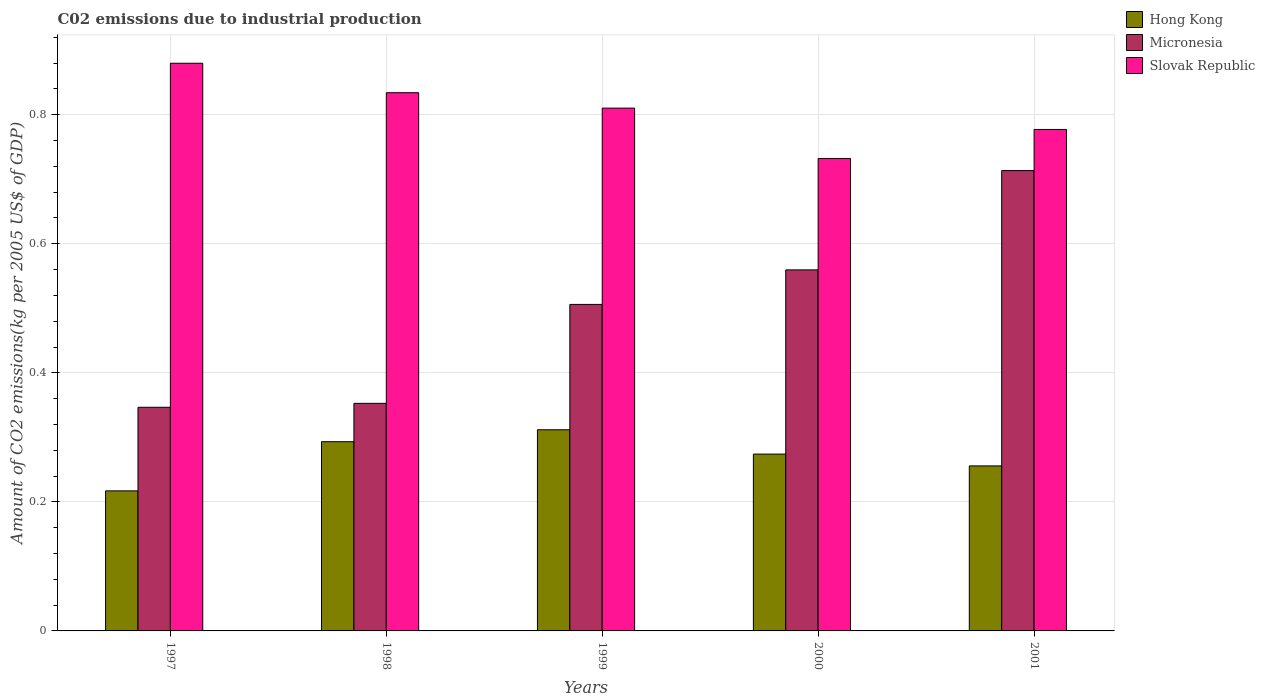How many different coloured bars are there?
Keep it short and to the point. 3. Are the number of bars on each tick of the X-axis equal?
Offer a terse response. Yes. What is the label of the 5th group of bars from the left?
Your answer should be very brief. 2001. In how many cases, is the number of bars for a given year not equal to the number of legend labels?
Offer a very short reply. 0. What is the amount of CO2 emitted due to industrial production in Slovak Republic in 2001?
Ensure brevity in your answer.  0.78. Across all years, what is the maximum amount of CO2 emitted due to industrial production in Micronesia?
Give a very brief answer. 0.71. Across all years, what is the minimum amount of CO2 emitted due to industrial production in Hong Kong?
Your response must be concise. 0.22. In which year was the amount of CO2 emitted due to industrial production in Hong Kong maximum?
Offer a terse response. 1999. What is the total amount of CO2 emitted due to industrial production in Hong Kong in the graph?
Provide a short and direct response. 1.35. What is the difference between the amount of CO2 emitted due to industrial production in Hong Kong in 1998 and that in 2000?
Keep it short and to the point. 0.02. What is the difference between the amount of CO2 emitted due to industrial production in Micronesia in 2000 and the amount of CO2 emitted due to industrial production in Slovak Republic in 1998?
Keep it short and to the point. -0.27. What is the average amount of CO2 emitted due to industrial production in Micronesia per year?
Give a very brief answer. 0.5. In the year 1997, what is the difference between the amount of CO2 emitted due to industrial production in Hong Kong and amount of CO2 emitted due to industrial production in Slovak Republic?
Offer a terse response. -0.66. In how many years, is the amount of CO2 emitted due to industrial production in Micronesia greater than 0.6000000000000001 kg?
Offer a very short reply. 1. What is the ratio of the amount of CO2 emitted due to industrial production in Slovak Republic in 1998 to that in 2001?
Offer a very short reply. 1.07. Is the amount of CO2 emitted due to industrial production in Slovak Republic in 1997 less than that in 1998?
Your answer should be compact. No. Is the difference between the amount of CO2 emitted due to industrial production in Hong Kong in 1997 and 1999 greater than the difference between the amount of CO2 emitted due to industrial production in Slovak Republic in 1997 and 1999?
Ensure brevity in your answer.  No. What is the difference between the highest and the second highest amount of CO2 emitted due to industrial production in Slovak Republic?
Your answer should be compact. 0.05. What is the difference between the highest and the lowest amount of CO2 emitted due to industrial production in Slovak Republic?
Your response must be concise. 0.15. Is the sum of the amount of CO2 emitted due to industrial production in Slovak Republic in 1998 and 2001 greater than the maximum amount of CO2 emitted due to industrial production in Micronesia across all years?
Keep it short and to the point. Yes. What does the 2nd bar from the left in 2001 represents?
Provide a succinct answer. Micronesia. What does the 3rd bar from the right in 1999 represents?
Keep it short and to the point. Hong Kong. Is it the case that in every year, the sum of the amount of CO2 emitted due to industrial production in Slovak Republic and amount of CO2 emitted due to industrial production in Micronesia is greater than the amount of CO2 emitted due to industrial production in Hong Kong?
Your answer should be very brief. Yes. Are the values on the major ticks of Y-axis written in scientific E-notation?
Your answer should be very brief. No. What is the title of the graph?
Provide a succinct answer. C02 emissions due to industrial production. Does "Canada" appear as one of the legend labels in the graph?
Make the answer very short. No. What is the label or title of the X-axis?
Ensure brevity in your answer.  Years. What is the label or title of the Y-axis?
Your response must be concise. Amount of CO2 emissions(kg per 2005 US$ of GDP). What is the Amount of CO2 emissions(kg per 2005 US$ of GDP) of Hong Kong in 1997?
Provide a short and direct response. 0.22. What is the Amount of CO2 emissions(kg per 2005 US$ of GDP) of Micronesia in 1997?
Ensure brevity in your answer.  0.35. What is the Amount of CO2 emissions(kg per 2005 US$ of GDP) in Slovak Republic in 1997?
Give a very brief answer. 0.88. What is the Amount of CO2 emissions(kg per 2005 US$ of GDP) of Hong Kong in 1998?
Your answer should be very brief. 0.29. What is the Amount of CO2 emissions(kg per 2005 US$ of GDP) in Micronesia in 1998?
Your answer should be very brief. 0.35. What is the Amount of CO2 emissions(kg per 2005 US$ of GDP) in Slovak Republic in 1998?
Your answer should be compact. 0.83. What is the Amount of CO2 emissions(kg per 2005 US$ of GDP) of Hong Kong in 1999?
Provide a succinct answer. 0.31. What is the Amount of CO2 emissions(kg per 2005 US$ of GDP) of Micronesia in 1999?
Make the answer very short. 0.51. What is the Amount of CO2 emissions(kg per 2005 US$ of GDP) in Slovak Republic in 1999?
Give a very brief answer. 0.81. What is the Amount of CO2 emissions(kg per 2005 US$ of GDP) in Hong Kong in 2000?
Ensure brevity in your answer.  0.27. What is the Amount of CO2 emissions(kg per 2005 US$ of GDP) of Micronesia in 2000?
Offer a very short reply. 0.56. What is the Amount of CO2 emissions(kg per 2005 US$ of GDP) in Slovak Republic in 2000?
Give a very brief answer. 0.73. What is the Amount of CO2 emissions(kg per 2005 US$ of GDP) in Hong Kong in 2001?
Offer a terse response. 0.26. What is the Amount of CO2 emissions(kg per 2005 US$ of GDP) in Micronesia in 2001?
Make the answer very short. 0.71. What is the Amount of CO2 emissions(kg per 2005 US$ of GDP) of Slovak Republic in 2001?
Your answer should be compact. 0.78. Across all years, what is the maximum Amount of CO2 emissions(kg per 2005 US$ of GDP) in Hong Kong?
Your answer should be compact. 0.31. Across all years, what is the maximum Amount of CO2 emissions(kg per 2005 US$ of GDP) of Micronesia?
Offer a terse response. 0.71. Across all years, what is the maximum Amount of CO2 emissions(kg per 2005 US$ of GDP) of Slovak Republic?
Make the answer very short. 0.88. Across all years, what is the minimum Amount of CO2 emissions(kg per 2005 US$ of GDP) of Hong Kong?
Your answer should be compact. 0.22. Across all years, what is the minimum Amount of CO2 emissions(kg per 2005 US$ of GDP) of Micronesia?
Make the answer very short. 0.35. Across all years, what is the minimum Amount of CO2 emissions(kg per 2005 US$ of GDP) in Slovak Republic?
Provide a short and direct response. 0.73. What is the total Amount of CO2 emissions(kg per 2005 US$ of GDP) in Hong Kong in the graph?
Offer a terse response. 1.35. What is the total Amount of CO2 emissions(kg per 2005 US$ of GDP) in Micronesia in the graph?
Your response must be concise. 2.48. What is the total Amount of CO2 emissions(kg per 2005 US$ of GDP) of Slovak Republic in the graph?
Your response must be concise. 4.03. What is the difference between the Amount of CO2 emissions(kg per 2005 US$ of GDP) in Hong Kong in 1997 and that in 1998?
Provide a short and direct response. -0.08. What is the difference between the Amount of CO2 emissions(kg per 2005 US$ of GDP) of Micronesia in 1997 and that in 1998?
Offer a very short reply. -0.01. What is the difference between the Amount of CO2 emissions(kg per 2005 US$ of GDP) in Slovak Republic in 1997 and that in 1998?
Your answer should be compact. 0.05. What is the difference between the Amount of CO2 emissions(kg per 2005 US$ of GDP) of Hong Kong in 1997 and that in 1999?
Make the answer very short. -0.09. What is the difference between the Amount of CO2 emissions(kg per 2005 US$ of GDP) of Micronesia in 1997 and that in 1999?
Offer a terse response. -0.16. What is the difference between the Amount of CO2 emissions(kg per 2005 US$ of GDP) of Slovak Republic in 1997 and that in 1999?
Provide a short and direct response. 0.07. What is the difference between the Amount of CO2 emissions(kg per 2005 US$ of GDP) in Hong Kong in 1997 and that in 2000?
Ensure brevity in your answer.  -0.06. What is the difference between the Amount of CO2 emissions(kg per 2005 US$ of GDP) of Micronesia in 1997 and that in 2000?
Provide a short and direct response. -0.21. What is the difference between the Amount of CO2 emissions(kg per 2005 US$ of GDP) in Slovak Republic in 1997 and that in 2000?
Make the answer very short. 0.15. What is the difference between the Amount of CO2 emissions(kg per 2005 US$ of GDP) in Hong Kong in 1997 and that in 2001?
Give a very brief answer. -0.04. What is the difference between the Amount of CO2 emissions(kg per 2005 US$ of GDP) of Micronesia in 1997 and that in 2001?
Make the answer very short. -0.37. What is the difference between the Amount of CO2 emissions(kg per 2005 US$ of GDP) in Slovak Republic in 1997 and that in 2001?
Offer a terse response. 0.1. What is the difference between the Amount of CO2 emissions(kg per 2005 US$ of GDP) of Hong Kong in 1998 and that in 1999?
Keep it short and to the point. -0.02. What is the difference between the Amount of CO2 emissions(kg per 2005 US$ of GDP) of Micronesia in 1998 and that in 1999?
Provide a short and direct response. -0.15. What is the difference between the Amount of CO2 emissions(kg per 2005 US$ of GDP) of Slovak Republic in 1998 and that in 1999?
Your response must be concise. 0.02. What is the difference between the Amount of CO2 emissions(kg per 2005 US$ of GDP) of Hong Kong in 1998 and that in 2000?
Offer a terse response. 0.02. What is the difference between the Amount of CO2 emissions(kg per 2005 US$ of GDP) in Micronesia in 1998 and that in 2000?
Make the answer very short. -0.21. What is the difference between the Amount of CO2 emissions(kg per 2005 US$ of GDP) in Slovak Republic in 1998 and that in 2000?
Your answer should be compact. 0.1. What is the difference between the Amount of CO2 emissions(kg per 2005 US$ of GDP) of Hong Kong in 1998 and that in 2001?
Keep it short and to the point. 0.04. What is the difference between the Amount of CO2 emissions(kg per 2005 US$ of GDP) in Micronesia in 1998 and that in 2001?
Make the answer very short. -0.36. What is the difference between the Amount of CO2 emissions(kg per 2005 US$ of GDP) in Slovak Republic in 1998 and that in 2001?
Your response must be concise. 0.06. What is the difference between the Amount of CO2 emissions(kg per 2005 US$ of GDP) in Hong Kong in 1999 and that in 2000?
Keep it short and to the point. 0.04. What is the difference between the Amount of CO2 emissions(kg per 2005 US$ of GDP) of Micronesia in 1999 and that in 2000?
Give a very brief answer. -0.05. What is the difference between the Amount of CO2 emissions(kg per 2005 US$ of GDP) of Slovak Republic in 1999 and that in 2000?
Offer a very short reply. 0.08. What is the difference between the Amount of CO2 emissions(kg per 2005 US$ of GDP) in Hong Kong in 1999 and that in 2001?
Provide a succinct answer. 0.06. What is the difference between the Amount of CO2 emissions(kg per 2005 US$ of GDP) in Micronesia in 1999 and that in 2001?
Provide a succinct answer. -0.21. What is the difference between the Amount of CO2 emissions(kg per 2005 US$ of GDP) of Slovak Republic in 1999 and that in 2001?
Your answer should be compact. 0.03. What is the difference between the Amount of CO2 emissions(kg per 2005 US$ of GDP) of Hong Kong in 2000 and that in 2001?
Keep it short and to the point. 0.02. What is the difference between the Amount of CO2 emissions(kg per 2005 US$ of GDP) in Micronesia in 2000 and that in 2001?
Make the answer very short. -0.15. What is the difference between the Amount of CO2 emissions(kg per 2005 US$ of GDP) of Slovak Republic in 2000 and that in 2001?
Keep it short and to the point. -0.05. What is the difference between the Amount of CO2 emissions(kg per 2005 US$ of GDP) in Hong Kong in 1997 and the Amount of CO2 emissions(kg per 2005 US$ of GDP) in Micronesia in 1998?
Make the answer very short. -0.14. What is the difference between the Amount of CO2 emissions(kg per 2005 US$ of GDP) of Hong Kong in 1997 and the Amount of CO2 emissions(kg per 2005 US$ of GDP) of Slovak Republic in 1998?
Make the answer very short. -0.62. What is the difference between the Amount of CO2 emissions(kg per 2005 US$ of GDP) in Micronesia in 1997 and the Amount of CO2 emissions(kg per 2005 US$ of GDP) in Slovak Republic in 1998?
Your answer should be very brief. -0.49. What is the difference between the Amount of CO2 emissions(kg per 2005 US$ of GDP) in Hong Kong in 1997 and the Amount of CO2 emissions(kg per 2005 US$ of GDP) in Micronesia in 1999?
Your answer should be compact. -0.29. What is the difference between the Amount of CO2 emissions(kg per 2005 US$ of GDP) in Hong Kong in 1997 and the Amount of CO2 emissions(kg per 2005 US$ of GDP) in Slovak Republic in 1999?
Offer a very short reply. -0.59. What is the difference between the Amount of CO2 emissions(kg per 2005 US$ of GDP) of Micronesia in 1997 and the Amount of CO2 emissions(kg per 2005 US$ of GDP) of Slovak Republic in 1999?
Offer a terse response. -0.46. What is the difference between the Amount of CO2 emissions(kg per 2005 US$ of GDP) in Hong Kong in 1997 and the Amount of CO2 emissions(kg per 2005 US$ of GDP) in Micronesia in 2000?
Your answer should be compact. -0.34. What is the difference between the Amount of CO2 emissions(kg per 2005 US$ of GDP) of Hong Kong in 1997 and the Amount of CO2 emissions(kg per 2005 US$ of GDP) of Slovak Republic in 2000?
Provide a short and direct response. -0.52. What is the difference between the Amount of CO2 emissions(kg per 2005 US$ of GDP) in Micronesia in 1997 and the Amount of CO2 emissions(kg per 2005 US$ of GDP) in Slovak Republic in 2000?
Offer a very short reply. -0.39. What is the difference between the Amount of CO2 emissions(kg per 2005 US$ of GDP) in Hong Kong in 1997 and the Amount of CO2 emissions(kg per 2005 US$ of GDP) in Micronesia in 2001?
Your response must be concise. -0.5. What is the difference between the Amount of CO2 emissions(kg per 2005 US$ of GDP) of Hong Kong in 1997 and the Amount of CO2 emissions(kg per 2005 US$ of GDP) of Slovak Republic in 2001?
Your answer should be very brief. -0.56. What is the difference between the Amount of CO2 emissions(kg per 2005 US$ of GDP) in Micronesia in 1997 and the Amount of CO2 emissions(kg per 2005 US$ of GDP) in Slovak Republic in 2001?
Your answer should be very brief. -0.43. What is the difference between the Amount of CO2 emissions(kg per 2005 US$ of GDP) of Hong Kong in 1998 and the Amount of CO2 emissions(kg per 2005 US$ of GDP) of Micronesia in 1999?
Your answer should be very brief. -0.21. What is the difference between the Amount of CO2 emissions(kg per 2005 US$ of GDP) in Hong Kong in 1998 and the Amount of CO2 emissions(kg per 2005 US$ of GDP) in Slovak Republic in 1999?
Provide a succinct answer. -0.52. What is the difference between the Amount of CO2 emissions(kg per 2005 US$ of GDP) of Micronesia in 1998 and the Amount of CO2 emissions(kg per 2005 US$ of GDP) of Slovak Republic in 1999?
Give a very brief answer. -0.46. What is the difference between the Amount of CO2 emissions(kg per 2005 US$ of GDP) in Hong Kong in 1998 and the Amount of CO2 emissions(kg per 2005 US$ of GDP) in Micronesia in 2000?
Give a very brief answer. -0.27. What is the difference between the Amount of CO2 emissions(kg per 2005 US$ of GDP) of Hong Kong in 1998 and the Amount of CO2 emissions(kg per 2005 US$ of GDP) of Slovak Republic in 2000?
Your answer should be very brief. -0.44. What is the difference between the Amount of CO2 emissions(kg per 2005 US$ of GDP) of Micronesia in 1998 and the Amount of CO2 emissions(kg per 2005 US$ of GDP) of Slovak Republic in 2000?
Offer a terse response. -0.38. What is the difference between the Amount of CO2 emissions(kg per 2005 US$ of GDP) of Hong Kong in 1998 and the Amount of CO2 emissions(kg per 2005 US$ of GDP) of Micronesia in 2001?
Your response must be concise. -0.42. What is the difference between the Amount of CO2 emissions(kg per 2005 US$ of GDP) in Hong Kong in 1998 and the Amount of CO2 emissions(kg per 2005 US$ of GDP) in Slovak Republic in 2001?
Provide a short and direct response. -0.48. What is the difference between the Amount of CO2 emissions(kg per 2005 US$ of GDP) in Micronesia in 1998 and the Amount of CO2 emissions(kg per 2005 US$ of GDP) in Slovak Republic in 2001?
Provide a short and direct response. -0.42. What is the difference between the Amount of CO2 emissions(kg per 2005 US$ of GDP) in Hong Kong in 1999 and the Amount of CO2 emissions(kg per 2005 US$ of GDP) in Micronesia in 2000?
Offer a very short reply. -0.25. What is the difference between the Amount of CO2 emissions(kg per 2005 US$ of GDP) of Hong Kong in 1999 and the Amount of CO2 emissions(kg per 2005 US$ of GDP) of Slovak Republic in 2000?
Provide a succinct answer. -0.42. What is the difference between the Amount of CO2 emissions(kg per 2005 US$ of GDP) in Micronesia in 1999 and the Amount of CO2 emissions(kg per 2005 US$ of GDP) in Slovak Republic in 2000?
Make the answer very short. -0.23. What is the difference between the Amount of CO2 emissions(kg per 2005 US$ of GDP) of Hong Kong in 1999 and the Amount of CO2 emissions(kg per 2005 US$ of GDP) of Micronesia in 2001?
Your answer should be very brief. -0.4. What is the difference between the Amount of CO2 emissions(kg per 2005 US$ of GDP) of Hong Kong in 1999 and the Amount of CO2 emissions(kg per 2005 US$ of GDP) of Slovak Republic in 2001?
Ensure brevity in your answer.  -0.47. What is the difference between the Amount of CO2 emissions(kg per 2005 US$ of GDP) of Micronesia in 1999 and the Amount of CO2 emissions(kg per 2005 US$ of GDP) of Slovak Republic in 2001?
Offer a terse response. -0.27. What is the difference between the Amount of CO2 emissions(kg per 2005 US$ of GDP) of Hong Kong in 2000 and the Amount of CO2 emissions(kg per 2005 US$ of GDP) of Micronesia in 2001?
Your response must be concise. -0.44. What is the difference between the Amount of CO2 emissions(kg per 2005 US$ of GDP) in Hong Kong in 2000 and the Amount of CO2 emissions(kg per 2005 US$ of GDP) in Slovak Republic in 2001?
Give a very brief answer. -0.5. What is the difference between the Amount of CO2 emissions(kg per 2005 US$ of GDP) in Micronesia in 2000 and the Amount of CO2 emissions(kg per 2005 US$ of GDP) in Slovak Republic in 2001?
Keep it short and to the point. -0.22. What is the average Amount of CO2 emissions(kg per 2005 US$ of GDP) of Hong Kong per year?
Ensure brevity in your answer.  0.27. What is the average Amount of CO2 emissions(kg per 2005 US$ of GDP) of Micronesia per year?
Ensure brevity in your answer.  0.5. What is the average Amount of CO2 emissions(kg per 2005 US$ of GDP) in Slovak Republic per year?
Make the answer very short. 0.81. In the year 1997, what is the difference between the Amount of CO2 emissions(kg per 2005 US$ of GDP) of Hong Kong and Amount of CO2 emissions(kg per 2005 US$ of GDP) of Micronesia?
Provide a succinct answer. -0.13. In the year 1997, what is the difference between the Amount of CO2 emissions(kg per 2005 US$ of GDP) in Hong Kong and Amount of CO2 emissions(kg per 2005 US$ of GDP) in Slovak Republic?
Keep it short and to the point. -0.66. In the year 1997, what is the difference between the Amount of CO2 emissions(kg per 2005 US$ of GDP) of Micronesia and Amount of CO2 emissions(kg per 2005 US$ of GDP) of Slovak Republic?
Offer a terse response. -0.53. In the year 1998, what is the difference between the Amount of CO2 emissions(kg per 2005 US$ of GDP) of Hong Kong and Amount of CO2 emissions(kg per 2005 US$ of GDP) of Micronesia?
Give a very brief answer. -0.06. In the year 1998, what is the difference between the Amount of CO2 emissions(kg per 2005 US$ of GDP) in Hong Kong and Amount of CO2 emissions(kg per 2005 US$ of GDP) in Slovak Republic?
Make the answer very short. -0.54. In the year 1998, what is the difference between the Amount of CO2 emissions(kg per 2005 US$ of GDP) of Micronesia and Amount of CO2 emissions(kg per 2005 US$ of GDP) of Slovak Republic?
Your response must be concise. -0.48. In the year 1999, what is the difference between the Amount of CO2 emissions(kg per 2005 US$ of GDP) in Hong Kong and Amount of CO2 emissions(kg per 2005 US$ of GDP) in Micronesia?
Keep it short and to the point. -0.19. In the year 1999, what is the difference between the Amount of CO2 emissions(kg per 2005 US$ of GDP) in Hong Kong and Amount of CO2 emissions(kg per 2005 US$ of GDP) in Slovak Republic?
Offer a very short reply. -0.5. In the year 1999, what is the difference between the Amount of CO2 emissions(kg per 2005 US$ of GDP) in Micronesia and Amount of CO2 emissions(kg per 2005 US$ of GDP) in Slovak Republic?
Ensure brevity in your answer.  -0.3. In the year 2000, what is the difference between the Amount of CO2 emissions(kg per 2005 US$ of GDP) in Hong Kong and Amount of CO2 emissions(kg per 2005 US$ of GDP) in Micronesia?
Give a very brief answer. -0.29. In the year 2000, what is the difference between the Amount of CO2 emissions(kg per 2005 US$ of GDP) in Hong Kong and Amount of CO2 emissions(kg per 2005 US$ of GDP) in Slovak Republic?
Make the answer very short. -0.46. In the year 2000, what is the difference between the Amount of CO2 emissions(kg per 2005 US$ of GDP) in Micronesia and Amount of CO2 emissions(kg per 2005 US$ of GDP) in Slovak Republic?
Your response must be concise. -0.17. In the year 2001, what is the difference between the Amount of CO2 emissions(kg per 2005 US$ of GDP) in Hong Kong and Amount of CO2 emissions(kg per 2005 US$ of GDP) in Micronesia?
Give a very brief answer. -0.46. In the year 2001, what is the difference between the Amount of CO2 emissions(kg per 2005 US$ of GDP) in Hong Kong and Amount of CO2 emissions(kg per 2005 US$ of GDP) in Slovak Republic?
Provide a succinct answer. -0.52. In the year 2001, what is the difference between the Amount of CO2 emissions(kg per 2005 US$ of GDP) of Micronesia and Amount of CO2 emissions(kg per 2005 US$ of GDP) of Slovak Republic?
Offer a very short reply. -0.06. What is the ratio of the Amount of CO2 emissions(kg per 2005 US$ of GDP) in Hong Kong in 1997 to that in 1998?
Provide a succinct answer. 0.74. What is the ratio of the Amount of CO2 emissions(kg per 2005 US$ of GDP) of Micronesia in 1997 to that in 1998?
Your answer should be very brief. 0.98. What is the ratio of the Amount of CO2 emissions(kg per 2005 US$ of GDP) of Slovak Republic in 1997 to that in 1998?
Give a very brief answer. 1.05. What is the ratio of the Amount of CO2 emissions(kg per 2005 US$ of GDP) in Hong Kong in 1997 to that in 1999?
Provide a succinct answer. 0.7. What is the ratio of the Amount of CO2 emissions(kg per 2005 US$ of GDP) in Micronesia in 1997 to that in 1999?
Your answer should be very brief. 0.69. What is the ratio of the Amount of CO2 emissions(kg per 2005 US$ of GDP) in Slovak Republic in 1997 to that in 1999?
Offer a terse response. 1.09. What is the ratio of the Amount of CO2 emissions(kg per 2005 US$ of GDP) of Hong Kong in 1997 to that in 2000?
Give a very brief answer. 0.79. What is the ratio of the Amount of CO2 emissions(kg per 2005 US$ of GDP) in Micronesia in 1997 to that in 2000?
Provide a succinct answer. 0.62. What is the ratio of the Amount of CO2 emissions(kg per 2005 US$ of GDP) in Slovak Republic in 1997 to that in 2000?
Your response must be concise. 1.2. What is the ratio of the Amount of CO2 emissions(kg per 2005 US$ of GDP) in Hong Kong in 1997 to that in 2001?
Keep it short and to the point. 0.85. What is the ratio of the Amount of CO2 emissions(kg per 2005 US$ of GDP) in Micronesia in 1997 to that in 2001?
Your answer should be very brief. 0.49. What is the ratio of the Amount of CO2 emissions(kg per 2005 US$ of GDP) in Slovak Republic in 1997 to that in 2001?
Keep it short and to the point. 1.13. What is the ratio of the Amount of CO2 emissions(kg per 2005 US$ of GDP) in Hong Kong in 1998 to that in 1999?
Give a very brief answer. 0.94. What is the ratio of the Amount of CO2 emissions(kg per 2005 US$ of GDP) in Micronesia in 1998 to that in 1999?
Ensure brevity in your answer.  0.7. What is the ratio of the Amount of CO2 emissions(kg per 2005 US$ of GDP) of Slovak Republic in 1998 to that in 1999?
Your answer should be compact. 1.03. What is the ratio of the Amount of CO2 emissions(kg per 2005 US$ of GDP) of Hong Kong in 1998 to that in 2000?
Provide a succinct answer. 1.07. What is the ratio of the Amount of CO2 emissions(kg per 2005 US$ of GDP) of Micronesia in 1998 to that in 2000?
Offer a terse response. 0.63. What is the ratio of the Amount of CO2 emissions(kg per 2005 US$ of GDP) in Slovak Republic in 1998 to that in 2000?
Your answer should be very brief. 1.14. What is the ratio of the Amount of CO2 emissions(kg per 2005 US$ of GDP) in Hong Kong in 1998 to that in 2001?
Your answer should be very brief. 1.15. What is the ratio of the Amount of CO2 emissions(kg per 2005 US$ of GDP) in Micronesia in 1998 to that in 2001?
Provide a succinct answer. 0.49. What is the ratio of the Amount of CO2 emissions(kg per 2005 US$ of GDP) in Slovak Republic in 1998 to that in 2001?
Offer a terse response. 1.07. What is the ratio of the Amount of CO2 emissions(kg per 2005 US$ of GDP) of Hong Kong in 1999 to that in 2000?
Provide a succinct answer. 1.14. What is the ratio of the Amount of CO2 emissions(kg per 2005 US$ of GDP) in Micronesia in 1999 to that in 2000?
Make the answer very short. 0.9. What is the ratio of the Amount of CO2 emissions(kg per 2005 US$ of GDP) in Slovak Republic in 1999 to that in 2000?
Your answer should be very brief. 1.11. What is the ratio of the Amount of CO2 emissions(kg per 2005 US$ of GDP) of Hong Kong in 1999 to that in 2001?
Your response must be concise. 1.22. What is the ratio of the Amount of CO2 emissions(kg per 2005 US$ of GDP) of Micronesia in 1999 to that in 2001?
Keep it short and to the point. 0.71. What is the ratio of the Amount of CO2 emissions(kg per 2005 US$ of GDP) in Slovak Republic in 1999 to that in 2001?
Offer a terse response. 1.04. What is the ratio of the Amount of CO2 emissions(kg per 2005 US$ of GDP) in Hong Kong in 2000 to that in 2001?
Give a very brief answer. 1.07. What is the ratio of the Amount of CO2 emissions(kg per 2005 US$ of GDP) in Micronesia in 2000 to that in 2001?
Your response must be concise. 0.78. What is the ratio of the Amount of CO2 emissions(kg per 2005 US$ of GDP) of Slovak Republic in 2000 to that in 2001?
Offer a terse response. 0.94. What is the difference between the highest and the second highest Amount of CO2 emissions(kg per 2005 US$ of GDP) of Hong Kong?
Provide a succinct answer. 0.02. What is the difference between the highest and the second highest Amount of CO2 emissions(kg per 2005 US$ of GDP) of Micronesia?
Provide a short and direct response. 0.15. What is the difference between the highest and the second highest Amount of CO2 emissions(kg per 2005 US$ of GDP) of Slovak Republic?
Offer a terse response. 0.05. What is the difference between the highest and the lowest Amount of CO2 emissions(kg per 2005 US$ of GDP) of Hong Kong?
Keep it short and to the point. 0.09. What is the difference between the highest and the lowest Amount of CO2 emissions(kg per 2005 US$ of GDP) of Micronesia?
Give a very brief answer. 0.37. What is the difference between the highest and the lowest Amount of CO2 emissions(kg per 2005 US$ of GDP) of Slovak Republic?
Your response must be concise. 0.15. 